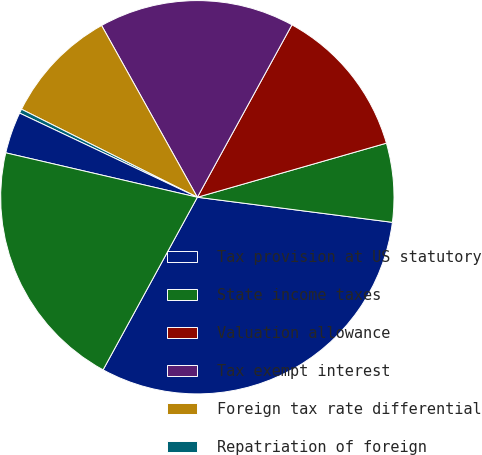Convert chart to OTSL. <chart><loc_0><loc_0><loc_500><loc_500><pie_chart><fcel>Tax provision at US statutory<fcel>State income taxes<fcel>Valuation allowance<fcel>Tax exempt interest<fcel>Foreign tax rate differential<fcel>Repatriation of foreign<fcel>Other - net<fcel>Effective income tax rate<nl><fcel>30.92%<fcel>6.47%<fcel>12.58%<fcel>16.08%<fcel>9.52%<fcel>0.35%<fcel>3.41%<fcel>20.67%<nl></chart> 